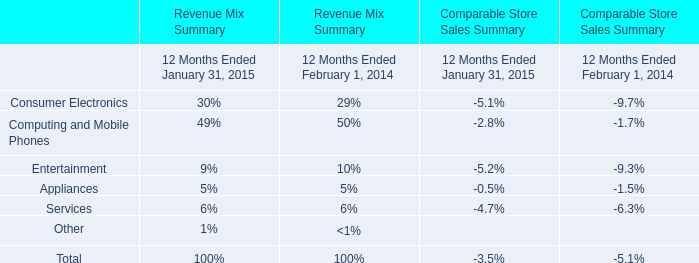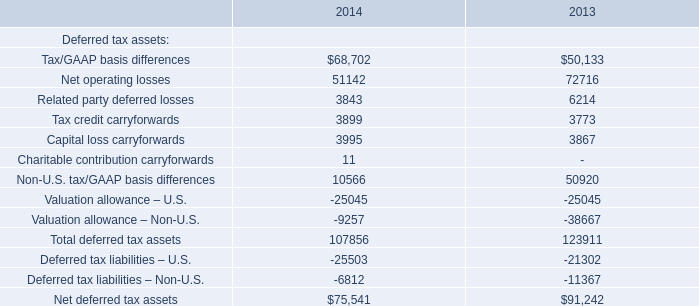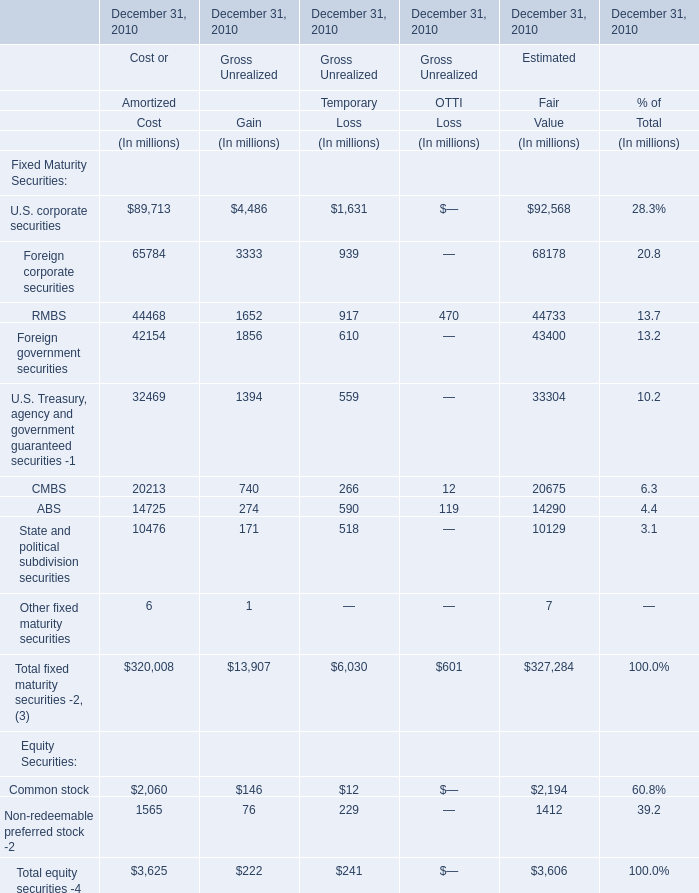In which section the sum of Foreign corporate securities has the highest value? 
Answer: Value. 